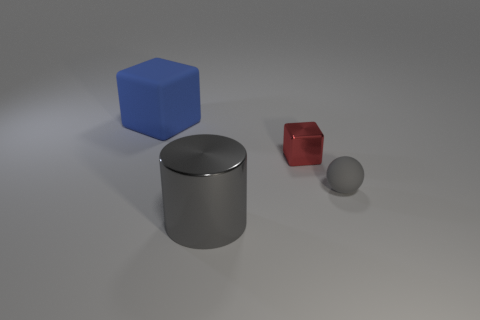Is the size of the blue cube the same as the red metallic thing?
Make the answer very short. No. What is the color of the cube behind the red shiny block?
Your answer should be compact. Blue. The red object that is made of the same material as the gray cylinder is what size?
Your answer should be very brief. Small. Is the size of the gray rubber ball the same as the block that is right of the blue rubber thing?
Your answer should be very brief. Yes. There is a block that is right of the large blue thing; what is its material?
Your response must be concise. Metal. There is a thing in front of the small rubber ball; what number of tiny red cubes are to the right of it?
Provide a succinct answer. 1. Is there a tiny green metallic thing that has the same shape as the small red metallic thing?
Offer a terse response. No. Does the rubber object in front of the blue block have the same size as the gray object that is on the left side of the tiny red metallic object?
Your answer should be compact. No. The gray object behind the big object that is right of the large blue thing is what shape?
Your answer should be very brief. Sphere. What number of spheres have the same size as the red shiny cube?
Your answer should be compact. 1. 